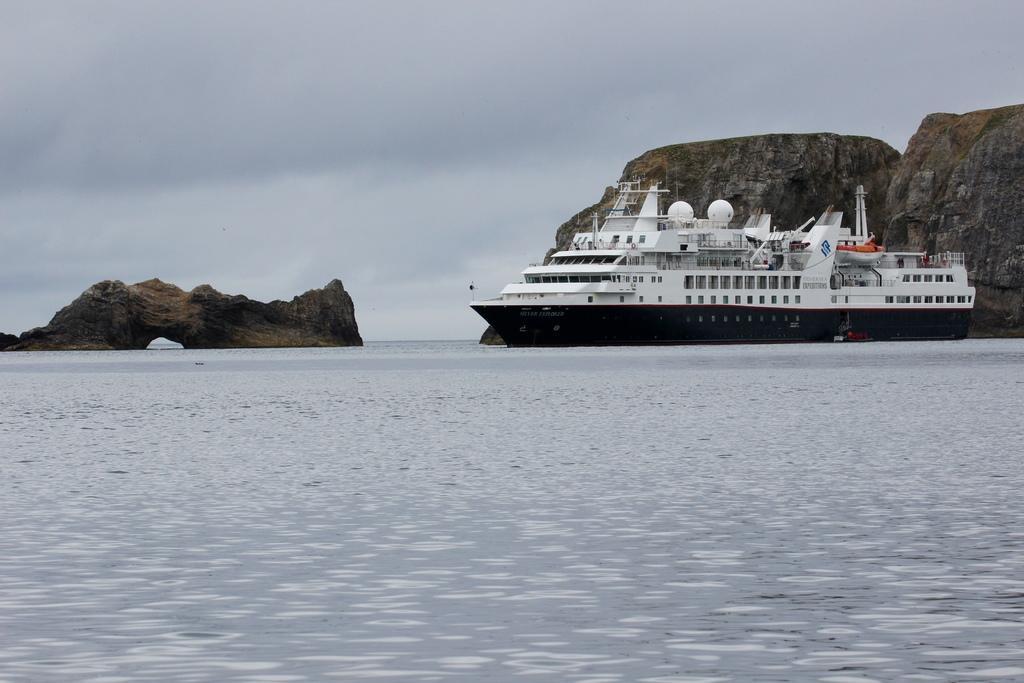Describe this image in one or two sentences. In this picture we can see water at the bottom, there is a ship in the water, in the background we can see hills, there is the sky at the top of the picture. 